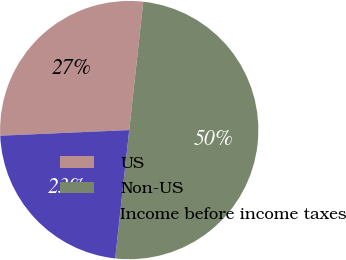Convert chart. <chart><loc_0><loc_0><loc_500><loc_500><pie_chart><fcel>US<fcel>Non-US<fcel>Income before income taxes<nl><fcel>27.43%<fcel>50.0%<fcel>22.57%<nl></chart> 